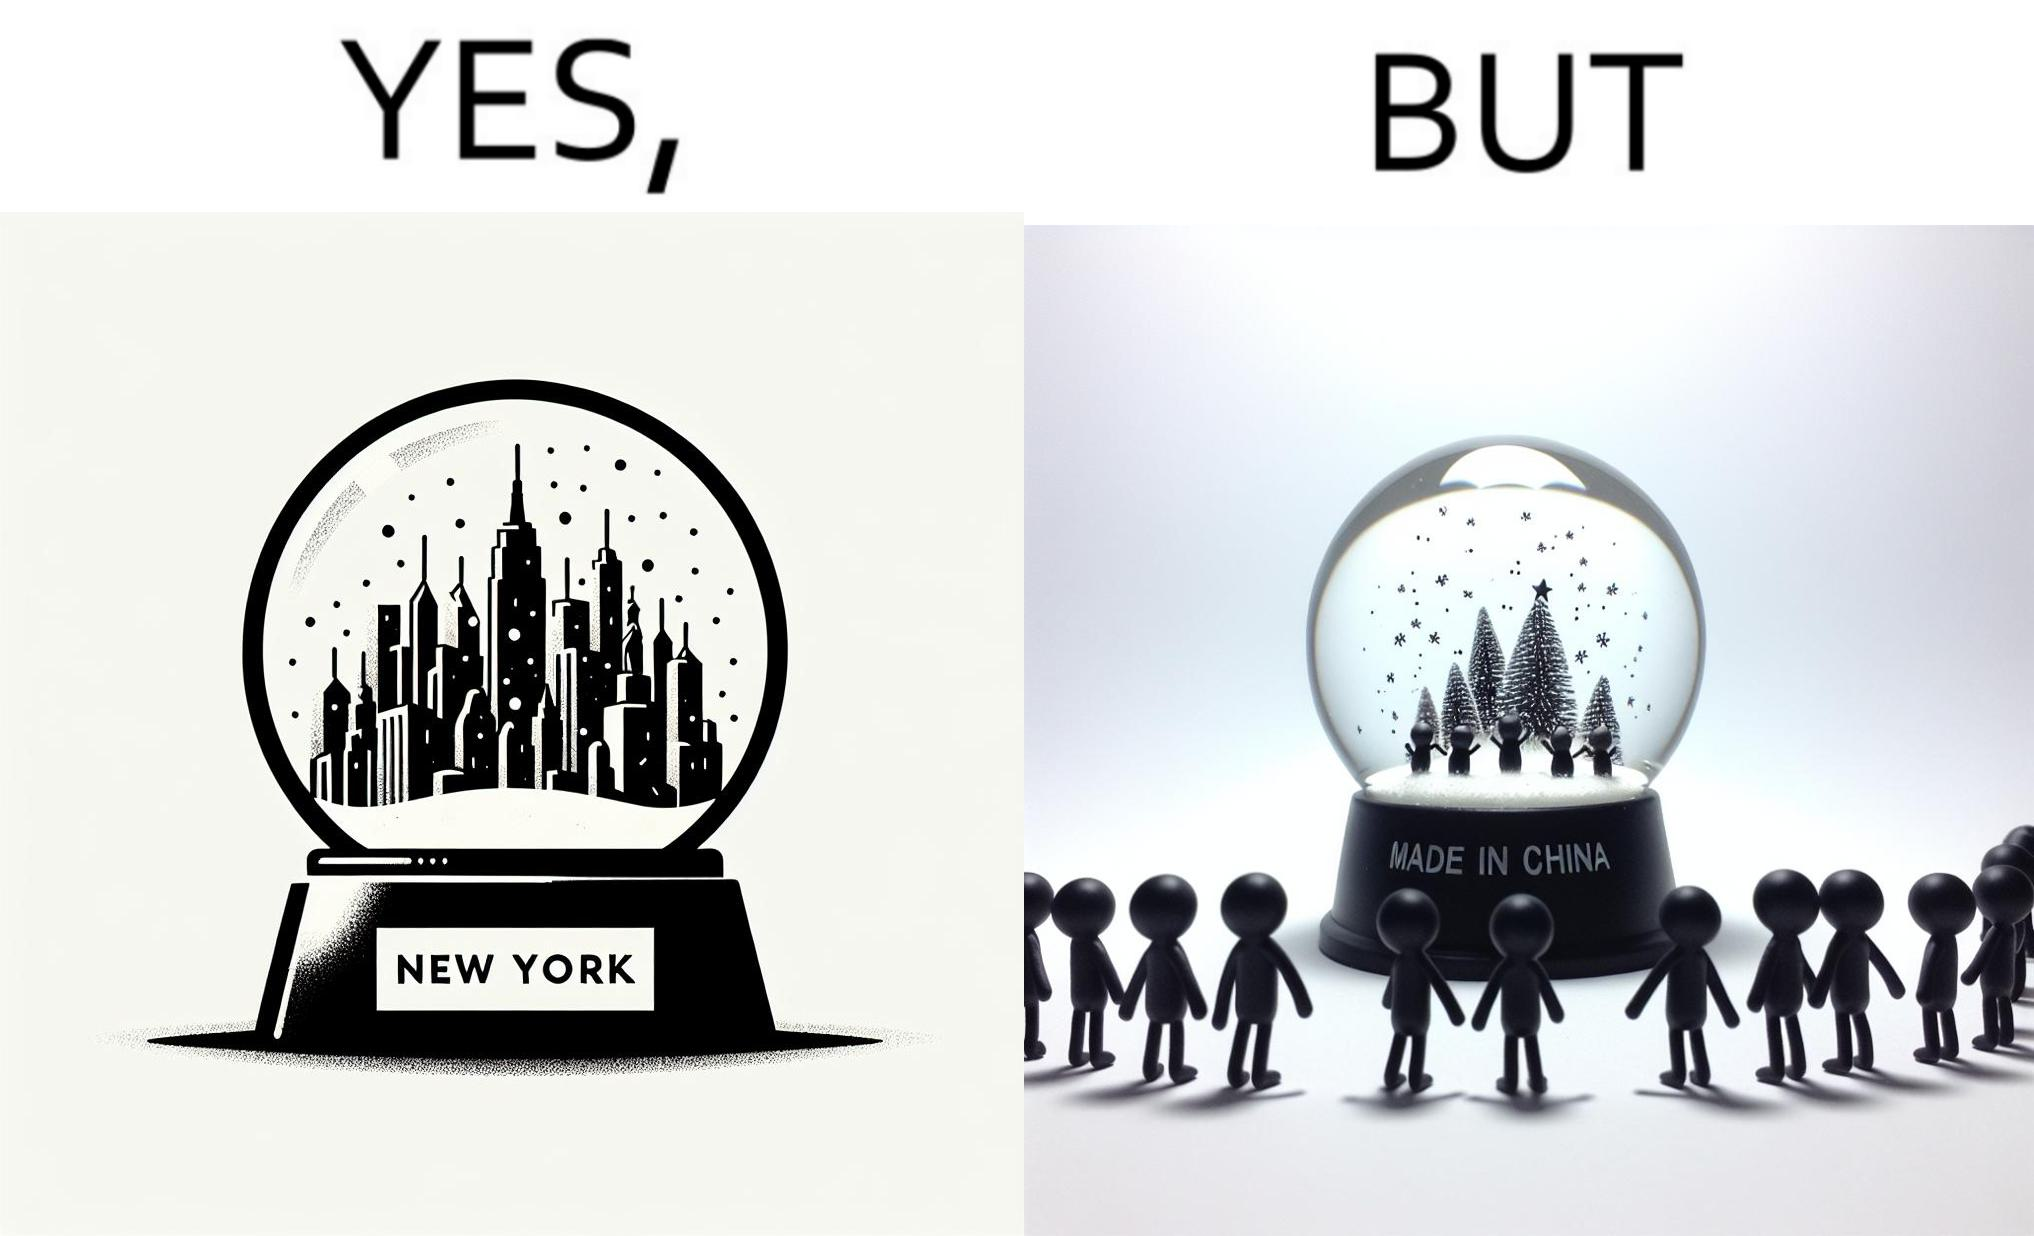What is shown in the left half versus the right half of this image? In the left part of the image: A snowglobe that says 'New York' In the right part of the image: Made in china' label on the snowglobe 